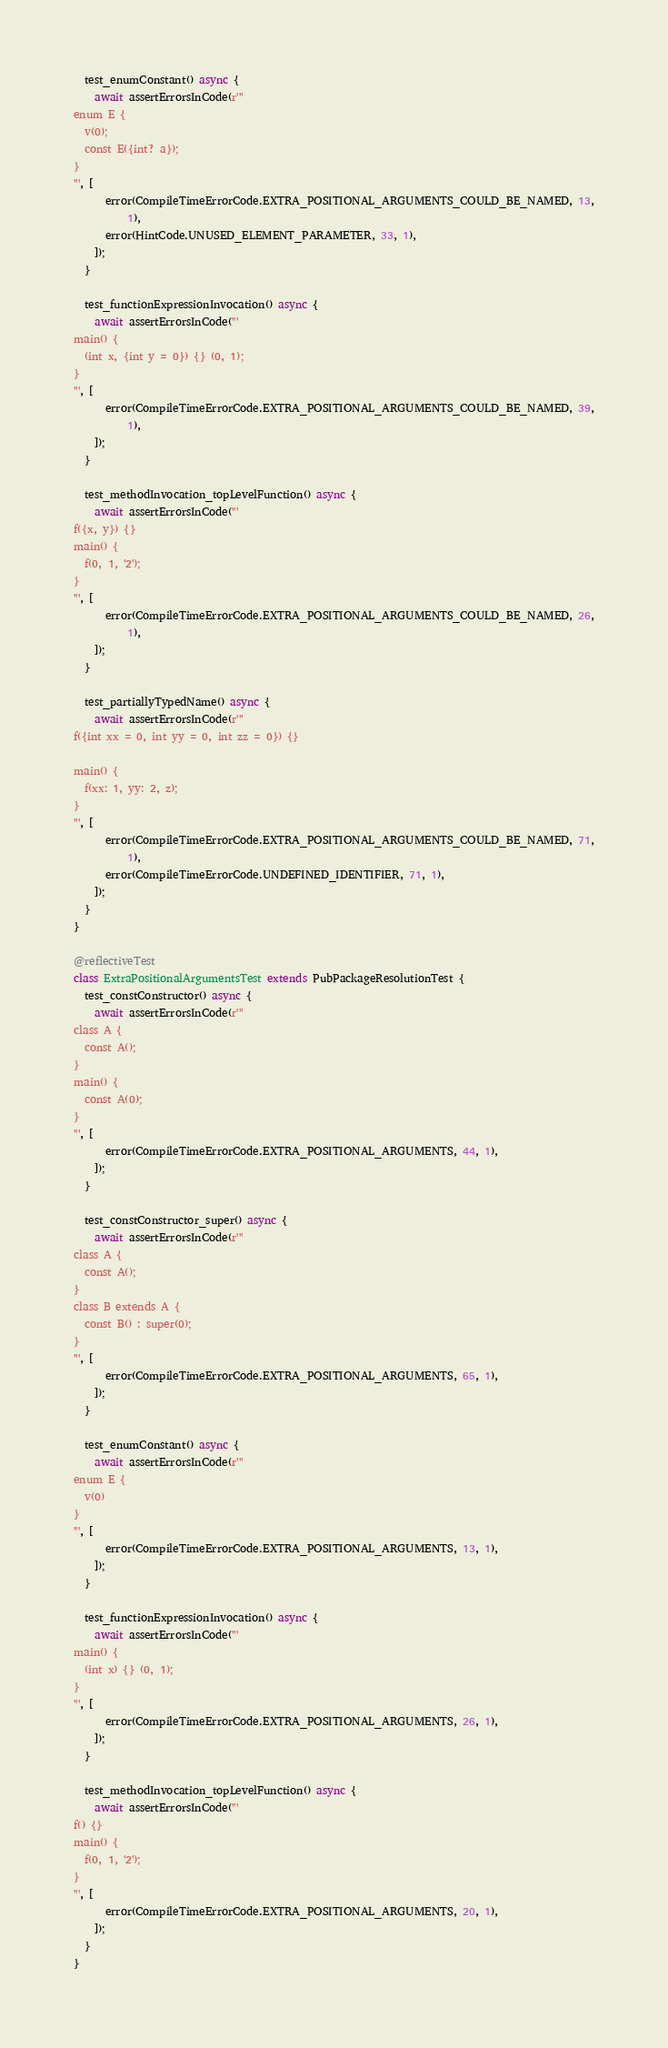<code> <loc_0><loc_0><loc_500><loc_500><_Dart_>  test_enumConstant() async {
    await assertErrorsInCode(r'''
enum E {
  v(0);
  const E({int? a});
}
''', [
      error(CompileTimeErrorCode.EXTRA_POSITIONAL_ARGUMENTS_COULD_BE_NAMED, 13,
          1),
      error(HintCode.UNUSED_ELEMENT_PARAMETER, 33, 1),
    ]);
  }

  test_functionExpressionInvocation() async {
    await assertErrorsInCode('''
main() {
  (int x, {int y = 0}) {} (0, 1);
}
''', [
      error(CompileTimeErrorCode.EXTRA_POSITIONAL_ARGUMENTS_COULD_BE_NAMED, 39,
          1),
    ]);
  }

  test_methodInvocation_topLevelFunction() async {
    await assertErrorsInCode('''
f({x, y}) {}
main() {
  f(0, 1, '2');
}
''', [
      error(CompileTimeErrorCode.EXTRA_POSITIONAL_ARGUMENTS_COULD_BE_NAMED, 26,
          1),
    ]);
  }

  test_partiallyTypedName() async {
    await assertErrorsInCode(r'''
f({int xx = 0, int yy = 0, int zz = 0}) {}

main() {
  f(xx: 1, yy: 2, z);
}
''', [
      error(CompileTimeErrorCode.EXTRA_POSITIONAL_ARGUMENTS_COULD_BE_NAMED, 71,
          1),
      error(CompileTimeErrorCode.UNDEFINED_IDENTIFIER, 71, 1),
    ]);
  }
}

@reflectiveTest
class ExtraPositionalArgumentsTest extends PubPackageResolutionTest {
  test_constConstructor() async {
    await assertErrorsInCode(r'''
class A {
  const A();
}
main() {
  const A(0);
}
''', [
      error(CompileTimeErrorCode.EXTRA_POSITIONAL_ARGUMENTS, 44, 1),
    ]);
  }

  test_constConstructor_super() async {
    await assertErrorsInCode(r'''
class A {
  const A();
}
class B extends A {
  const B() : super(0);
}
''', [
      error(CompileTimeErrorCode.EXTRA_POSITIONAL_ARGUMENTS, 65, 1),
    ]);
  }

  test_enumConstant() async {
    await assertErrorsInCode(r'''
enum E {
  v(0)
}
''', [
      error(CompileTimeErrorCode.EXTRA_POSITIONAL_ARGUMENTS, 13, 1),
    ]);
  }

  test_functionExpressionInvocation() async {
    await assertErrorsInCode('''
main() {
  (int x) {} (0, 1);
}
''', [
      error(CompileTimeErrorCode.EXTRA_POSITIONAL_ARGUMENTS, 26, 1),
    ]);
  }

  test_methodInvocation_topLevelFunction() async {
    await assertErrorsInCode('''
f() {}
main() {
  f(0, 1, '2');
}
''', [
      error(CompileTimeErrorCode.EXTRA_POSITIONAL_ARGUMENTS, 20, 1),
    ]);
  }
}
</code> 